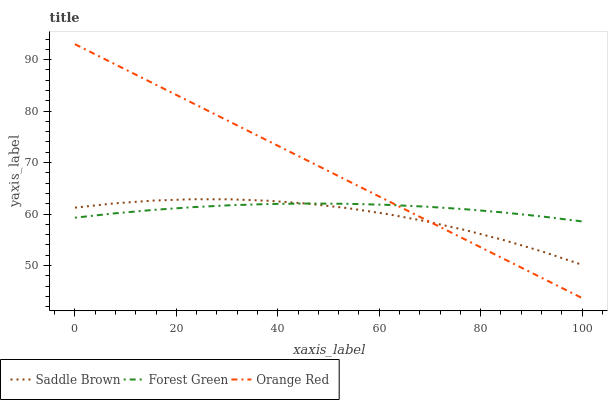Does Saddle Brown have the minimum area under the curve?
Answer yes or no. Yes. Does Orange Red have the maximum area under the curve?
Answer yes or no. Yes. Does Orange Red have the minimum area under the curve?
Answer yes or no. No. Does Saddle Brown have the maximum area under the curve?
Answer yes or no. No. Is Orange Red the smoothest?
Answer yes or no. Yes. Is Saddle Brown the roughest?
Answer yes or no. Yes. Is Saddle Brown the smoothest?
Answer yes or no. No. Is Orange Red the roughest?
Answer yes or no. No. Does Orange Red have the lowest value?
Answer yes or no. Yes. Does Saddle Brown have the lowest value?
Answer yes or no. No. Does Orange Red have the highest value?
Answer yes or no. Yes. Does Saddle Brown have the highest value?
Answer yes or no. No. Does Saddle Brown intersect Forest Green?
Answer yes or no. Yes. Is Saddle Brown less than Forest Green?
Answer yes or no. No. Is Saddle Brown greater than Forest Green?
Answer yes or no. No. 